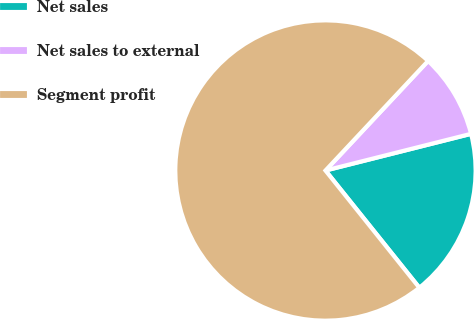<chart> <loc_0><loc_0><loc_500><loc_500><pie_chart><fcel>Net sales<fcel>Net sales to external<fcel>Segment profit<nl><fcel>18.18%<fcel>9.09%<fcel>72.73%<nl></chart> 